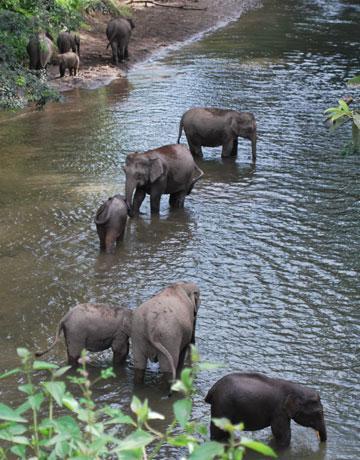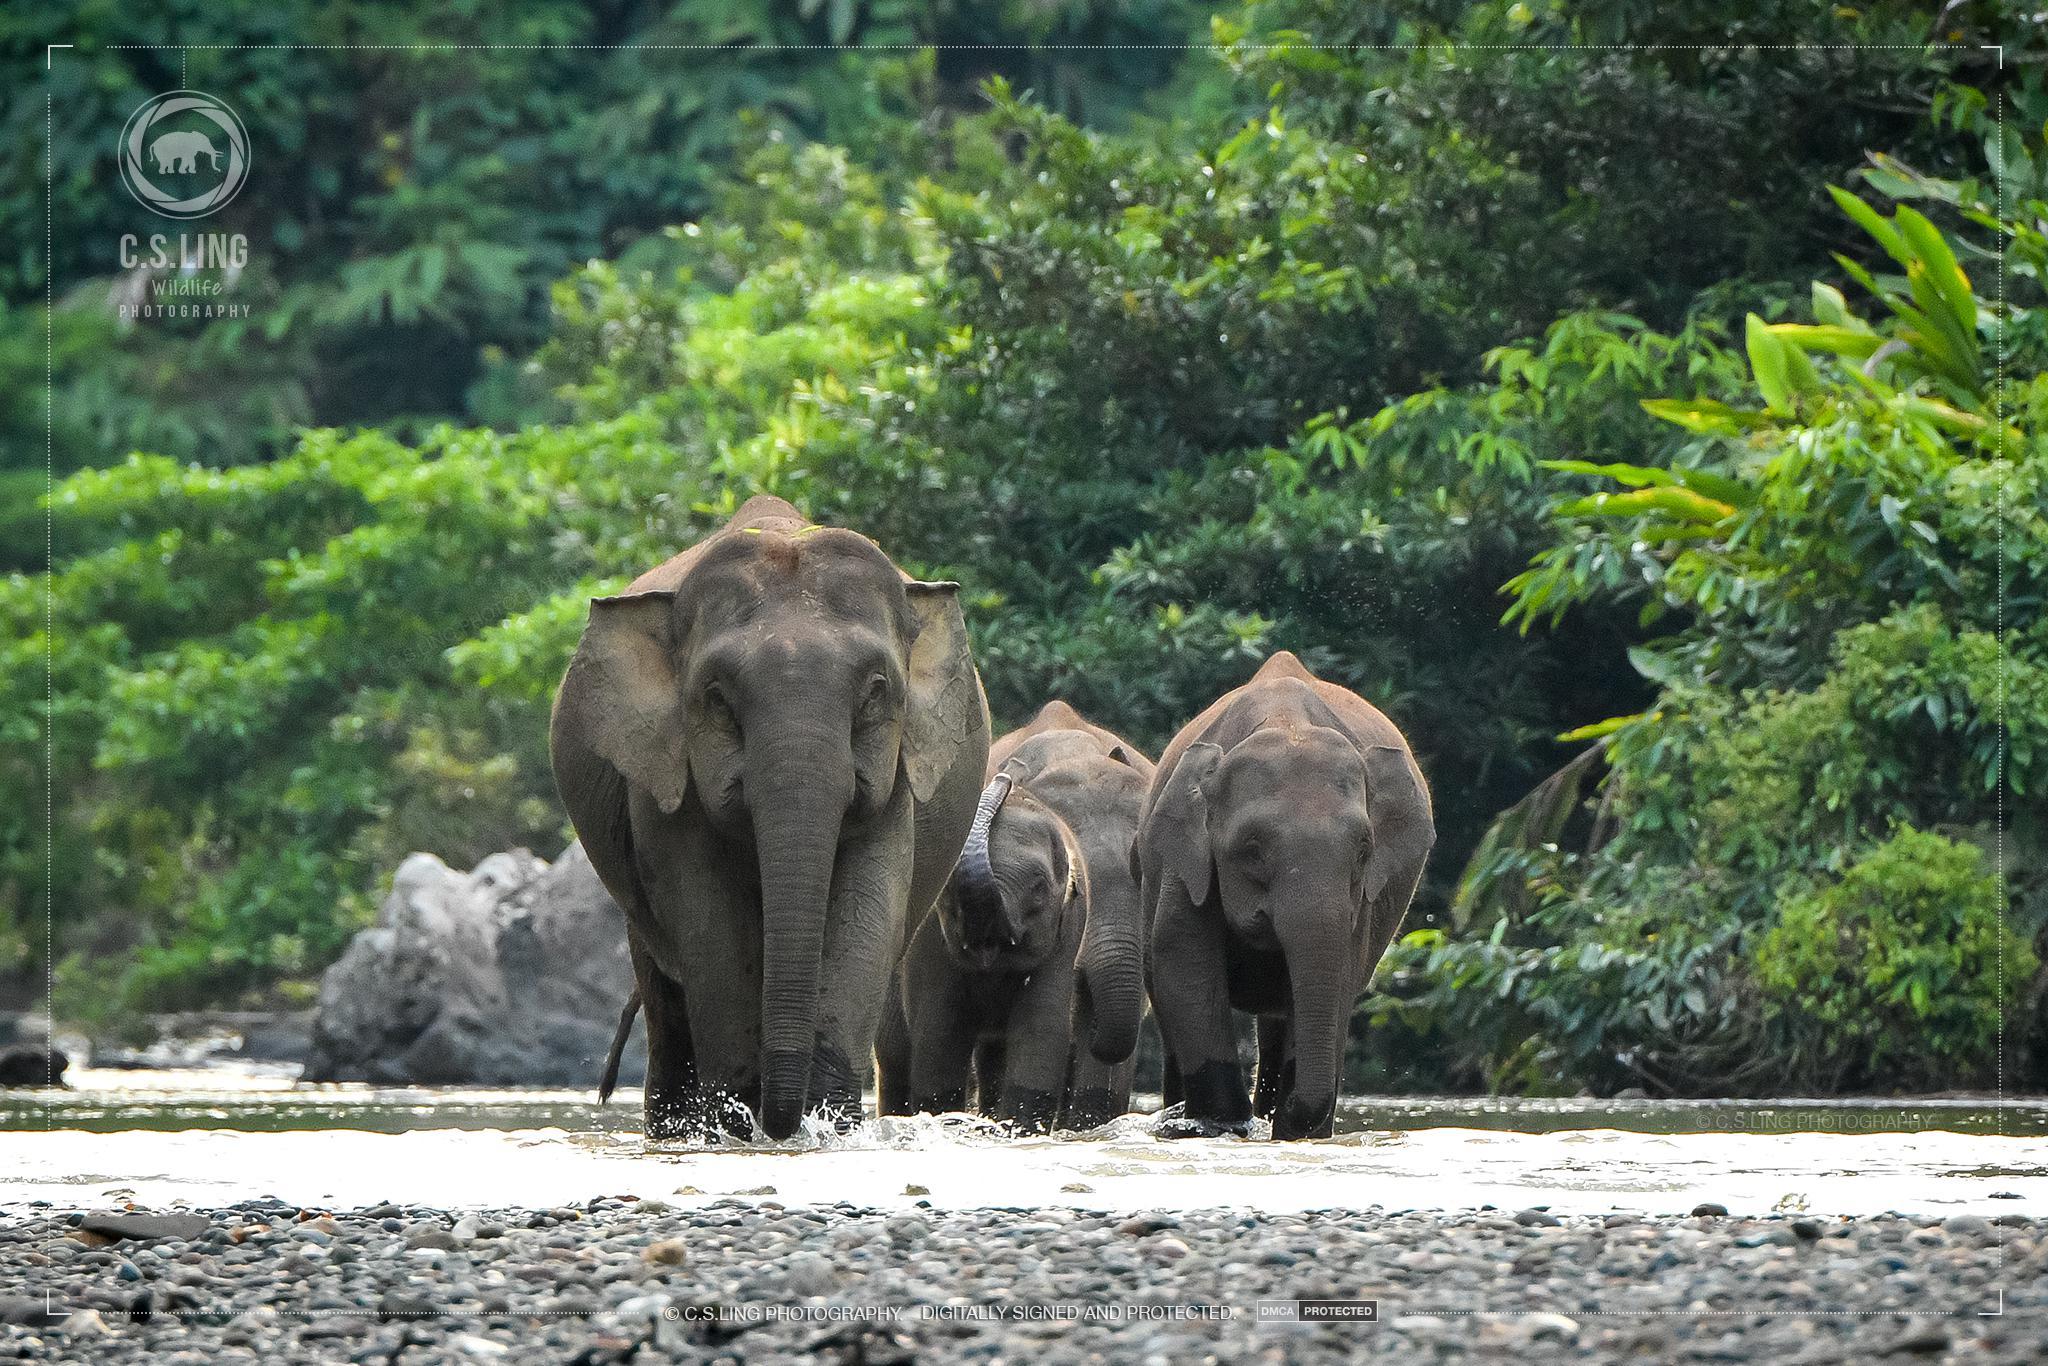The first image is the image on the left, the second image is the image on the right. Assess this claim about the two images: "Elephants are interacting with water.". Correct or not? Answer yes or no. Yes. 